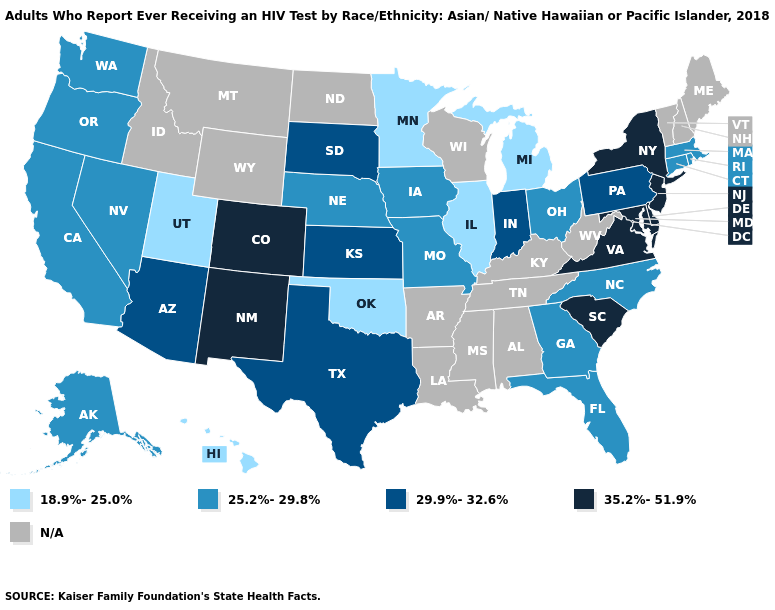What is the value of Maine?
Answer briefly. N/A. What is the lowest value in the South?
Be succinct. 18.9%-25.0%. What is the value of Maryland?
Write a very short answer. 35.2%-51.9%. Name the states that have a value in the range 25.2%-29.8%?
Keep it brief. Alaska, California, Connecticut, Florida, Georgia, Iowa, Massachusetts, Missouri, Nebraska, Nevada, North Carolina, Ohio, Oregon, Rhode Island, Washington. What is the lowest value in the USA?
Give a very brief answer. 18.9%-25.0%. Name the states that have a value in the range N/A?
Quick response, please. Alabama, Arkansas, Idaho, Kentucky, Louisiana, Maine, Mississippi, Montana, New Hampshire, North Dakota, Tennessee, Vermont, West Virginia, Wisconsin, Wyoming. Name the states that have a value in the range 29.9%-32.6%?
Write a very short answer. Arizona, Indiana, Kansas, Pennsylvania, South Dakota, Texas. Does the map have missing data?
Short answer required. Yes. What is the value of Michigan?
Give a very brief answer. 18.9%-25.0%. What is the value of Arizona?
Short answer required. 29.9%-32.6%. Name the states that have a value in the range 25.2%-29.8%?
Give a very brief answer. Alaska, California, Connecticut, Florida, Georgia, Iowa, Massachusetts, Missouri, Nebraska, Nevada, North Carolina, Ohio, Oregon, Rhode Island, Washington. Does the map have missing data?
Give a very brief answer. Yes. What is the value of Minnesota?
Concise answer only. 18.9%-25.0%. Name the states that have a value in the range 29.9%-32.6%?
Short answer required. Arizona, Indiana, Kansas, Pennsylvania, South Dakota, Texas. Among the states that border New Mexico , which have the lowest value?
Be succinct. Oklahoma, Utah. 